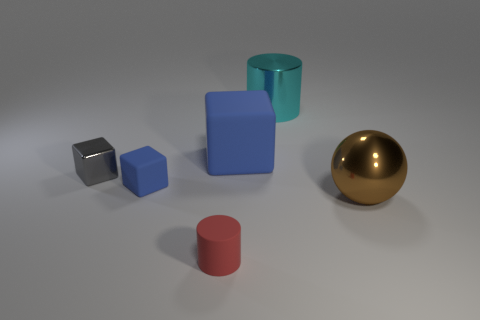Are there the same number of small blue rubber cubes behind the large cyan object and gray things?
Your answer should be compact. No. Are there any big rubber objects that have the same color as the metal cylinder?
Your answer should be very brief. No. Is the red rubber thing the same size as the brown sphere?
Ensure brevity in your answer.  No. How big is the blue rubber block that is left of the blue thing on the right side of the tiny red matte thing?
Give a very brief answer. Small. What size is the metallic object that is both in front of the shiny cylinder and on the right side of the red thing?
Your answer should be compact. Large. How many blue objects have the same size as the gray cube?
Your answer should be compact. 1. How many rubber objects are big blue objects or cubes?
Your answer should be compact. 2. What is the size of the thing that is the same color as the big matte block?
Your response must be concise. Small. There is a thing that is right of the cylinder behind the large brown ball; what is it made of?
Provide a short and direct response. Metal. What number of things are large green metallic objects or objects that are to the right of the tiny blue thing?
Make the answer very short. 4. 